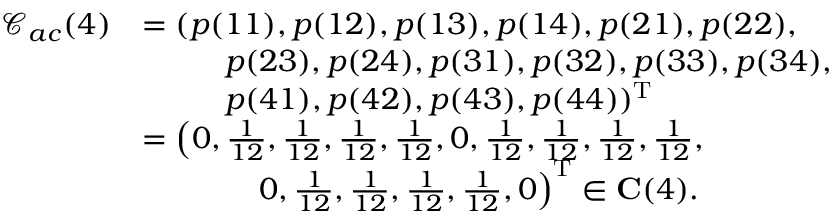Convert formula to latex. <formula><loc_0><loc_0><loc_500><loc_500>\begin{array} { r l } { \mathcal { C } _ { a c } ( 4 ) } & { = ( p ( 1 1 ) , p ( 1 2 ) , p ( 1 3 ) , p ( 1 4 ) , p ( 2 1 ) , p ( 2 2 ) , } \\ & { p ( 2 3 ) , p ( 2 4 ) , p ( 3 1 ) , p ( 3 2 ) , p ( 3 3 ) , p ( 3 4 ) , } \\ & { p ( 4 1 ) , p ( 4 2 ) , p ( 4 3 ) , p ( 4 4 ) ) ^ { T } } \\ & { = \left ( 0 , \frac { 1 } { 1 2 } , \frac { 1 } { 1 2 } , \frac { 1 } { 1 2 } , \frac { 1 } { 1 2 } , 0 , \frac { 1 } { 1 2 } , \frac { 1 } { 1 2 } , \frac { 1 } { 1 2 } , \frac { 1 } { 1 2 } , } \\ & { 0 , \frac { 1 } { 1 2 } , \frac { 1 } { 1 2 } , \frac { 1 } { 1 2 } , \frac { 1 } { 1 2 } , 0 \right ) ^ { T } \in C ( 4 ) . } \end{array}</formula> 